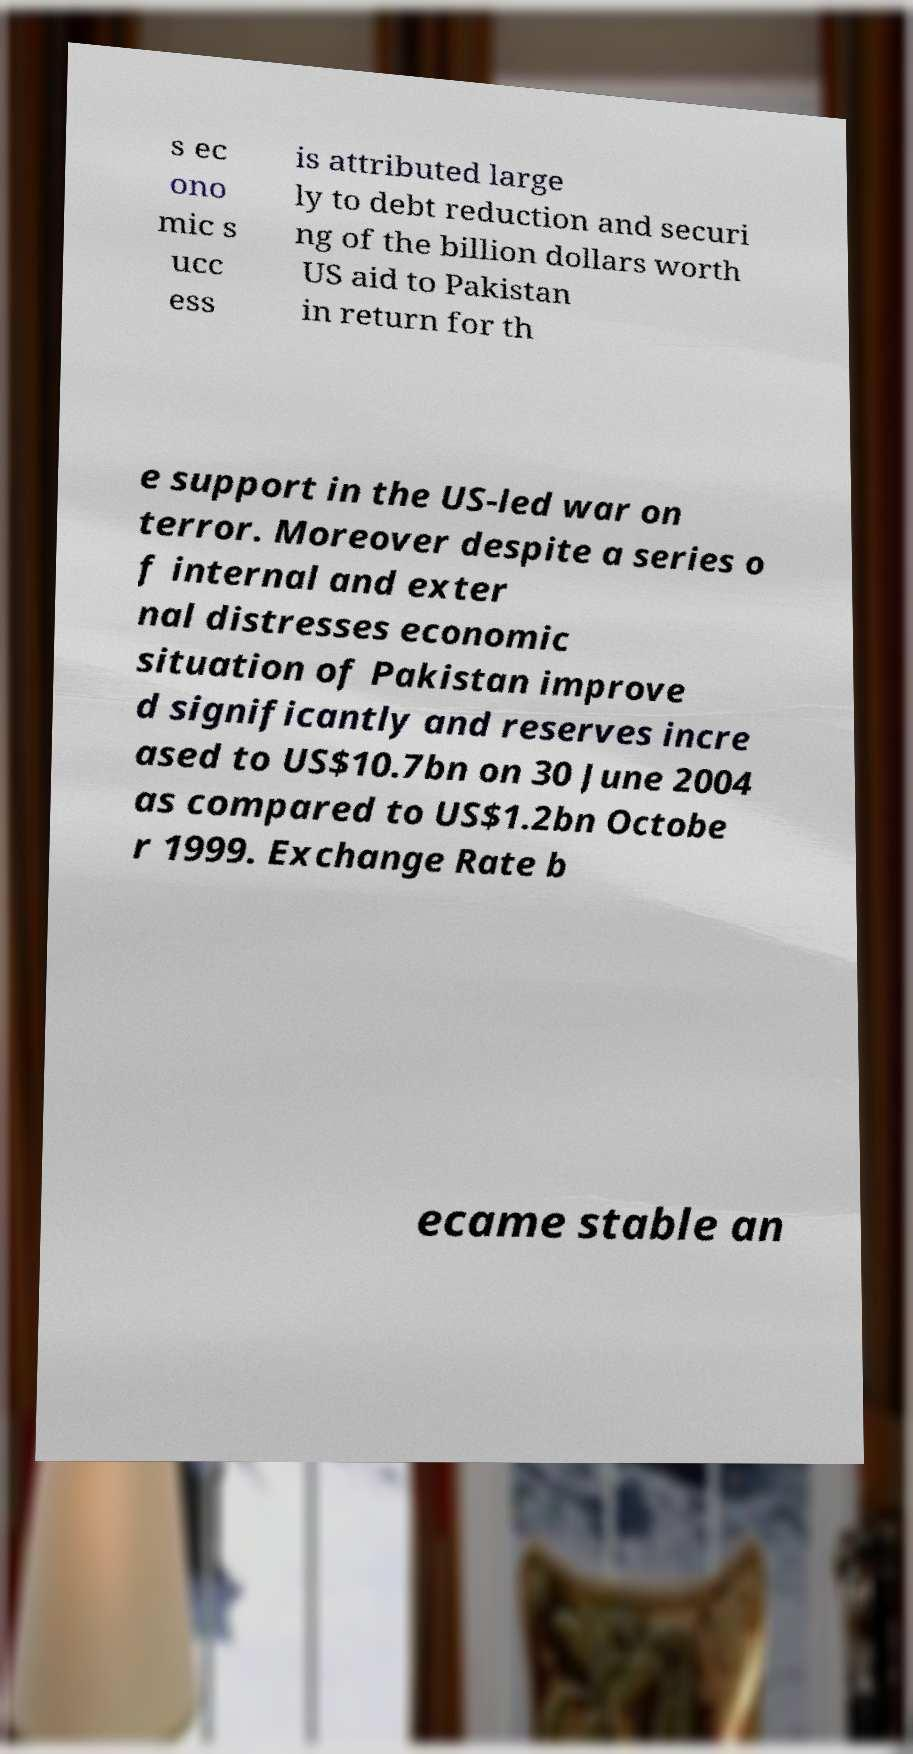Can you accurately transcribe the text from the provided image for me? s ec ono mic s ucc ess is attributed large ly to debt reduction and securi ng of the billion dollars worth US aid to Pakistan in return for th e support in the US-led war on terror. Moreover despite a series o f internal and exter nal distresses economic situation of Pakistan improve d significantly and reserves incre ased to US$10.7bn on 30 June 2004 as compared to US$1.2bn Octobe r 1999. Exchange Rate b ecame stable an 